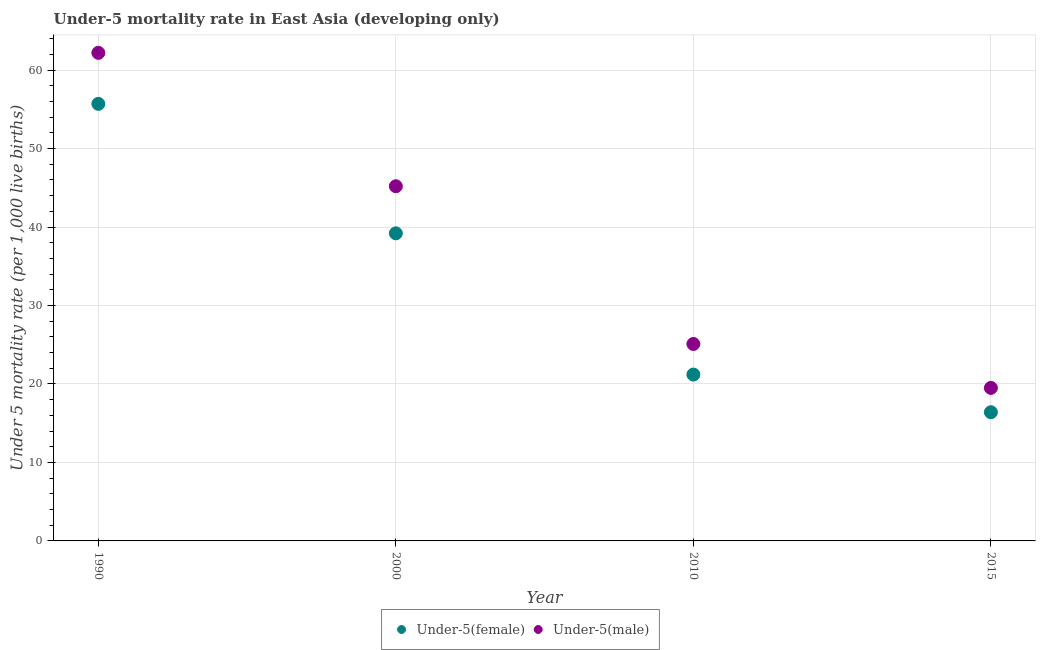How many different coloured dotlines are there?
Your response must be concise. 2. Is the number of dotlines equal to the number of legend labels?
Keep it short and to the point. Yes. What is the under-5 male mortality rate in 1990?
Give a very brief answer. 62.2. Across all years, what is the maximum under-5 male mortality rate?
Ensure brevity in your answer.  62.2. Across all years, what is the minimum under-5 male mortality rate?
Give a very brief answer. 19.5. In which year was the under-5 female mortality rate maximum?
Keep it short and to the point. 1990. In which year was the under-5 male mortality rate minimum?
Give a very brief answer. 2015. What is the total under-5 male mortality rate in the graph?
Keep it short and to the point. 152. What is the difference between the under-5 female mortality rate in 1990 and that in 2015?
Ensure brevity in your answer.  39.3. What is the difference between the under-5 male mortality rate in 2000 and the under-5 female mortality rate in 2015?
Ensure brevity in your answer.  28.8. What is the average under-5 female mortality rate per year?
Ensure brevity in your answer.  33.12. In the year 2015, what is the difference between the under-5 female mortality rate and under-5 male mortality rate?
Provide a succinct answer. -3.1. What is the ratio of the under-5 female mortality rate in 2000 to that in 2015?
Give a very brief answer. 2.39. What is the difference between the highest and the second highest under-5 male mortality rate?
Provide a short and direct response. 17. What is the difference between the highest and the lowest under-5 female mortality rate?
Your answer should be very brief. 39.3. Is the sum of the under-5 female mortality rate in 1990 and 2015 greater than the maximum under-5 male mortality rate across all years?
Provide a short and direct response. Yes. Does the under-5 female mortality rate monotonically increase over the years?
Provide a succinct answer. No. Is the under-5 male mortality rate strictly greater than the under-5 female mortality rate over the years?
Give a very brief answer. Yes. Is the under-5 female mortality rate strictly less than the under-5 male mortality rate over the years?
Ensure brevity in your answer.  Yes. What is the difference between two consecutive major ticks on the Y-axis?
Ensure brevity in your answer.  10. Are the values on the major ticks of Y-axis written in scientific E-notation?
Your response must be concise. No. Does the graph contain any zero values?
Your answer should be very brief. No. Where does the legend appear in the graph?
Ensure brevity in your answer.  Bottom center. How are the legend labels stacked?
Your response must be concise. Horizontal. What is the title of the graph?
Offer a terse response. Under-5 mortality rate in East Asia (developing only). What is the label or title of the X-axis?
Ensure brevity in your answer.  Year. What is the label or title of the Y-axis?
Keep it short and to the point. Under 5 mortality rate (per 1,0 live births). What is the Under 5 mortality rate (per 1,000 live births) in Under-5(female) in 1990?
Offer a terse response. 55.7. What is the Under 5 mortality rate (per 1,000 live births) in Under-5(male) in 1990?
Provide a succinct answer. 62.2. What is the Under 5 mortality rate (per 1,000 live births) of Under-5(female) in 2000?
Provide a succinct answer. 39.2. What is the Under 5 mortality rate (per 1,000 live births) of Under-5(male) in 2000?
Make the answer very short. 45.2. What is the Under 5 mortality rate (per 1,000 live births) in Under-5(female) in 2010?
Your response must be concise. 21.2. What is the Under 5 mortality rate (per 1,000 live births) in Under-5(male) in 2010?
Your response must be concise. 25.1. What is the Under 5 mortality rate (per 1,000 live births) in Under-5(female) in 2015?
Make the answer very short. 16.4. What is the Under 5 mortality rate (per 1,000 live births) of Under-5(male) in 2015?
Keep it short and to the point. 19.5. Across all years, what is the maximum Under 5 mortality rate (per 1,000 live births) in Under-5(female)?
Ensure brevity in your answer.  55.7. Across all years, what is the maximum Under 5 mortality rate (per 1,000 live births) of Under-5(male)?
Your answer should be compact. 62.2. Across all years, what is the minimum Under 5 mortality rate (per 1,000 live births) in Under-5(female)?
Offer a very short reply. 16.4. Across all years, what is the minimum Under 5 mortality rate (per 1,000 live births) of Under-5(male)?
Your answer should be compact. 19.5. What is the total Under 5 mortality rate (per 1,000 live births) of Under-5(female) in the graph?
Ensure brevity in your answer.  132.5. What is the total Under 5 mortality rate (per 1,000 live births) of Under-5(male) in the graph?
Your answer should be very brief. 152. What is the difference between the Under 5 mortality rate (per 1,000 live births) of Under-5(female) in 1990 and that in 2010?
Offer a terse response. 34.5. What is the difference between the Under 5 mortality rate (per 1,000 live births) of Under-5(male) in 1990 and that in 2010?
Offer a terse response. 37.1. What is the difference between the Under 5 mortality rate (per 1,000 live births) of Under-5(female) in 1990 and that in 2015?
Ensure brevity in your answer.  39.3. What is the difference between the Under 5 mortality rate (per 1,000 live births) in Under-5(male) in 1990 and that in 2015?
Offer a terse response. 42.7. What is the difference between the Under 5 mortality rate (per 1,000 live births) of Under-5(male) in 2000 and that in 2010?
Your answer should be very brief. 20.1. What is the difference between the Under 5 mortality rate (per 1,000 live births) in Under-5(female) in 2000 and that in 2015?
Give a very brief answer. 22.8. What is the difference between the Under 5 mortality rate (per 1,000 live births) in Under-5(male) in 2000 and that in 2015?
Ensure brevity in your answer.  25.7. What is the difference between the Under 5 mortality rate (per 1,000 live births) in Under-5(female) in 1990 and the Under 5 mortality rate (per 1,000 live births) in Under-5(male) in 2000?
Your answer should be compact. 10.5. What is the difference between the Under 5 mortality rate (per 1,000 live births) of Under-5(female) in 1990 and the Under 5 mortality rate (per 1,000 live births) of Under-5(male) in 2010?
Offer a terse response. 30.6. What is the difference between the Under 5 mortality rate (per 1,000 live births) in Under-5(female) in 1990 and the Under 5 mortality rate (per 1,000 live births) in Under-5(male) in 2015?
Ensure brevity in your answer.  36.2. What is the difference between the Under 5 mortality rate (per 1,000 live births) in Under-5(female) in 2000 and the Under 5 mortality rate (per 1,000 live births) in Under-5(male) in 2010?
Keep it short and to the point. 14.1. What is the difference between the Under 5 mortality rate (per 1,000 live births) in Under-5(female) in 2000 and the Under 5 mortality rate (per 1,000 live births) in Under-5(male) in 2015?
Provide a short and direct response. 19.7. What is the difference between the Under 5 mortality rate (per 1,000 live births) in Under-5(female) in 2010 and the Under 5 mortality rate (per 1,000 live births) in Under-5(male) in 2015?
Your response must be concise. 1.7. What is the average Under 5 mortality rate (per 1,000 live births) in Under-5(female) per year?
Offer a terse response. 33.12. In the year 1990, what is the difference between the Under 5 mortality rate (per 1,000 live births) in Under-5(female) and Under 5 mortality rate (per 1,000 live births) in Under-5(male)?
Make the answer very short. -6.5. In the year 2000, what is the difference between the Under 5 mortality rate (per 1,000 live births) in Under-5(female) and Under 5 mortality rate (per 1,000 live births) in Under-5(male)?
Ensure brevity in your answer.  -6. In the year 2010, what is the difference between the Under 5 mortality rate (per 1,000 live births) in Under-5(female) and Under 5 mortality rate (per 1,000 live births) in Under-5(male)?
Give a very brief answer. -3.9. What is the ratio of the Under 5 mortality rate (per 1,000 live births) of Under-5(female) in 1990 to that in 2000?
Ensure brevity in your answer.  1.42. What is the ratio of the Under 5 mortality rate (per 1,000 live births) in Under-5(male) in 1990 to that in 2000?
Provide a succinct answer. 1.38. What is the ratio of the Under 5 mortality rate (per 1,000 live births) in Under-5(female) in 1990 to that in 2010?
Your answer should be very brief. 2.63. What is the ratio of the Under 5 mortality rate (per 1,000 live births) in Under-5(male) in 1990 to that in 2010?
Offer a very short reply. 2.48. What is the ratio of the Under 5 mortality rate (per 1,000 live births) of Under-5(female) in 1990 to that in 2015?
Provide a succinct answer. 3.4. What is the ratio of the Under 5 mortality rate (per 1,000 live births) of Under-5(male) in 1990 to that in 2015?
Your response must be concise. 3.19. What is the ratio of the Under 5 mortality rate (per 1,000 live births) of Under-5(female) in 2000 to that in 2010?
Ensure brevity in your answer.  1.85. What is the ratio of the Under 5 mortality rate (per 1,000 live births) of Under-5(male) in 2000 to that in 2010?
Provide a succinct answer. 1.8. What is the ratio of the Under 5 mortality rate (per 1,000 live births) of Under-5(female) in 2000 to that in 2015?
Your response must be concise. 2.39. What is the ratio of the Under 5 mortality rate (per 1,000 live births) in Under-5(male) in 2000 to that in 2015?
Provide a short and direct response. 2.32. What is the ratio of the Under 5 mortality rate (per 1,000 live births) in Under-5(female) in 2010 to that in 2015?
Keep it short and to the point. 1.29. What is the ratio of the Under 5 mortality rate (per 1,000 live births) of Under-5(male) in 2010 to that in 2015?
Your answer should be compact. 1.29. What is the difference between the highest and the second highest Under 5 mortality rate (per 1,000 live births) in Under-5(female)?
Your answer should be very brief. 16.5. What is the difference between the highest and the second highest Under 5 mortality rate (per 1,000 live births) in Under-5(male)?
Your answer should be very brief. 17. What is the difference between the highest and the lowest Under 5 mortality rate (per 1,000 live births) of Under-5(female)?
Provide a succinct answer. 39.3. What is the difference between the highest and the lowest Under 5 mortality rate (per 1,000 live births) in Under-5(male)?
Offer a terse response. 42.7. 